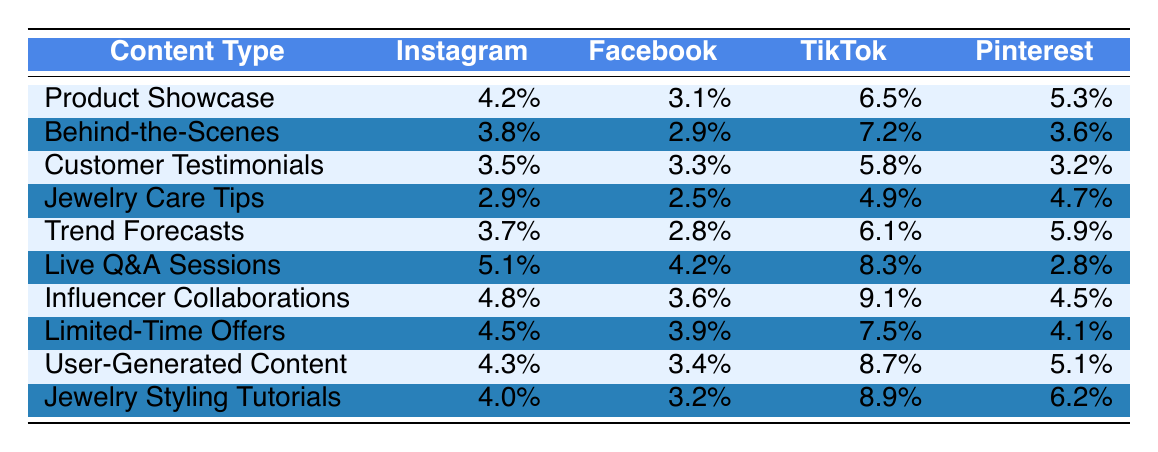What is the engagement rate for Product Showcase on TikTok? The engagement rate for Product Showcase is found under the TikTok column, where it states 6.5%.
Answer: 6.5% Which platform shows the highest engagement rate for Live Q&A Sessions? By comparing the engagement rates for Live Q&A Sessions across all platforms, TikTok has the highest at 8.3%.
Answer: TikTok What is the difference in engagement rates between Customer Testimonials on Instagram and Facebook? The engagement rate for Customer Testimonials on Instagram is 3.5% and on Facebook, it is 3.3%. The difference is calculated as 3.5% - 3.3% = 0.2%.
Answer: 0.2% True or False: Behind-the-Scenes content has a higher engagement rate on Pinterest than on Facebook. The engagement rate for Behind-the-Scenes on Pinterest is 3.6% and on Facebook, it is 2.9%. Since 3.6% > 2.9%, the statement is true.
Answer: True What is the average engagement rate for User-Generated Content across all platforms? The engagement rates for User-Generated Content are 4.3% (Instagram), 3.4% (Facebook), 8.7% (TikTok), and 5.1% (Pinterest). To find the average: (4.3 + 3.4 + 8.7 + 5.1) / 4 = 21.5 / 4 = 5.375%.
Answer: 5.375% Which type of content has the lowest engagement rate on Instagram? Looking at the Instagram engagement rates, Jewelry Care Tips has the lowest at 2.9%.
Answer: Jewelry Care Tips 